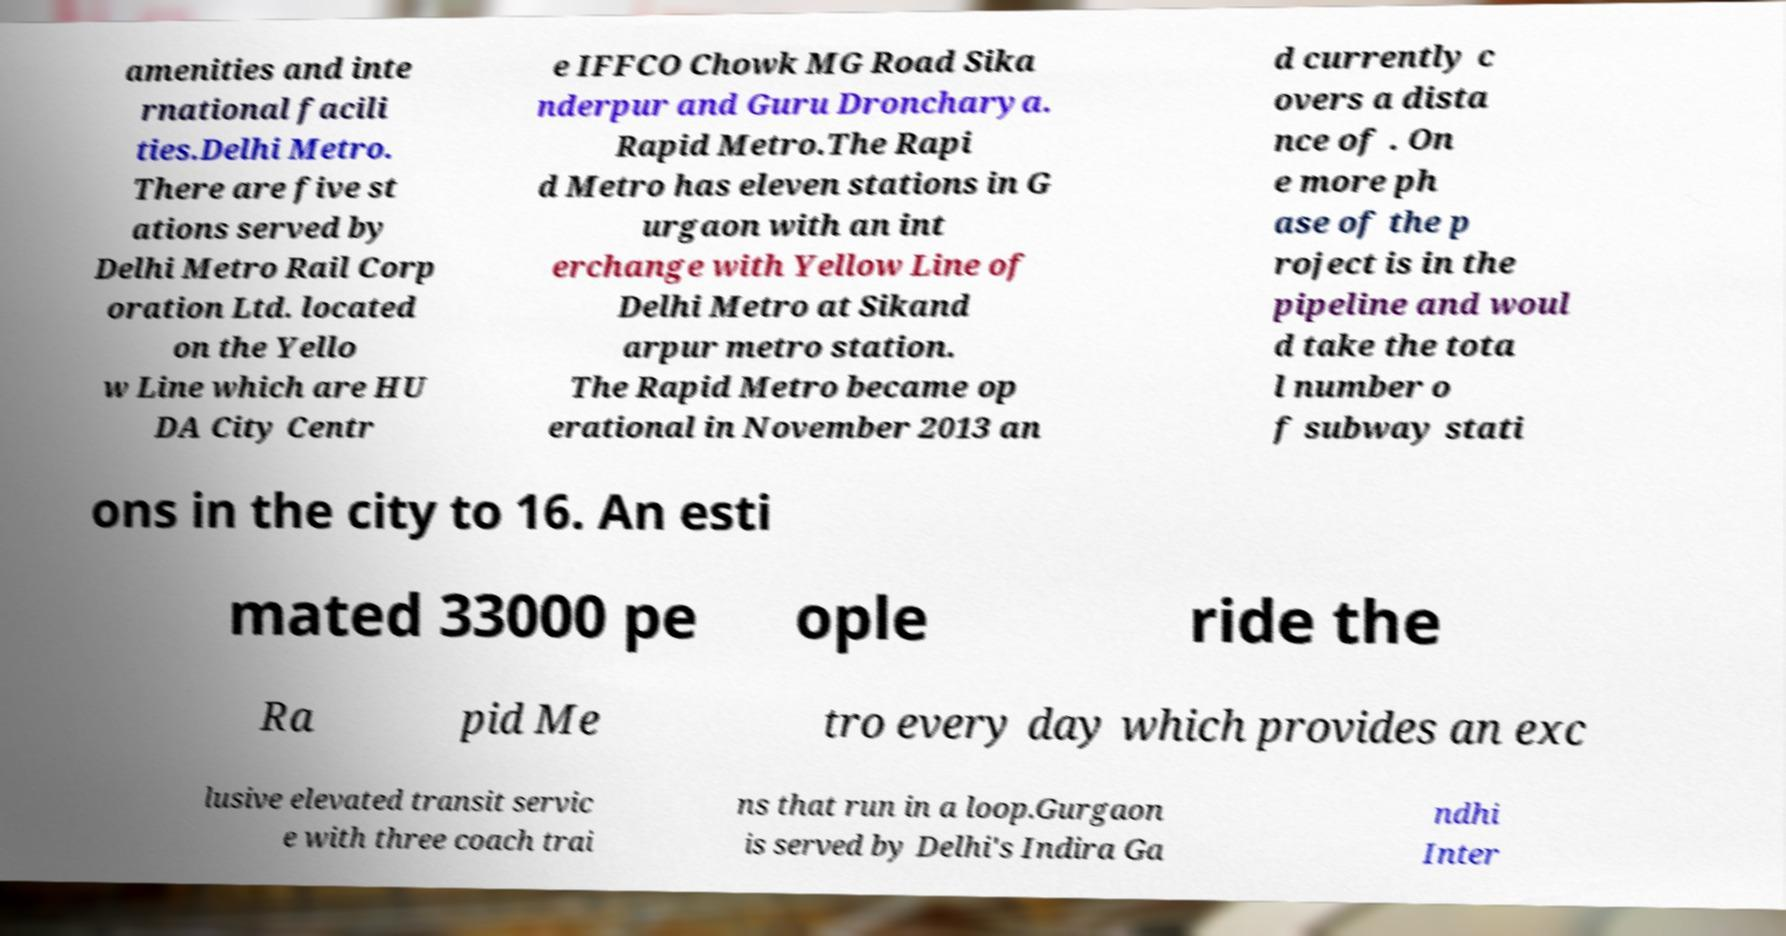I need the written content from this picture converted into text. Can you do that? amenities and inte rnational facili ties.Delhi Metro. There are five st ations served by Delhi Metro Rail Corp oration Ltd. located on the Yello w Line which are HU DA City Centr e IFFCO Chowk MG Road Sika nderpur and Guru Droncharya. Rapid Metro.The Rapi d Metro has eleven stations in G urgaon with an int erchange with Yellow Line of Delhi Metro at Sikand arpur metro station. The Rapid Metro became op erational in November 2013 an d currently c overs a dista nce of . On e more ph ase of the p roject is in the pipeline and woul d take the tota l number o f subway stati ons in the city to 16. An esti mated 33000 pe ople ride the Ra pid Me tro every day which provides an exc lusive elevated transit servic e with three coach trai ns that run in a loop.Gurgaon is served by Delhi's Indira Ga ndhi Inter 